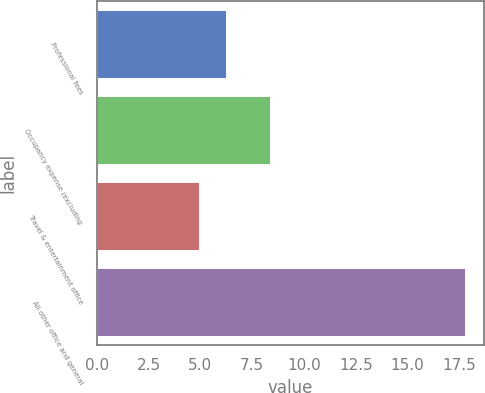Convert chart. <chart><loc_0><loc_0><loc_500><loc_500><bar_chart><fcel>Professional fees<fcel>Occupancy expense (excluding<fcel>Travel & entertainment office<fcel>All other office and general<nl><fcel>6.28<fcel>8.4<fcel>5<fcel>17.8<nl></chart> 